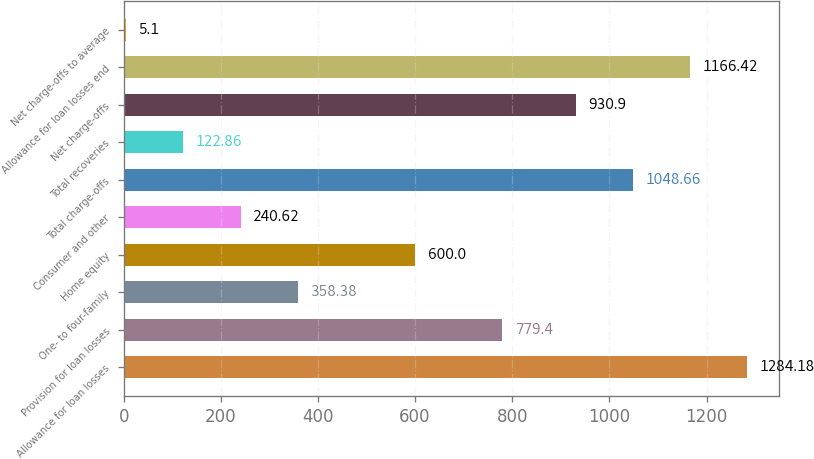<chart> <loc_0><loc_0><loc_500><loc_500><bar_chart><fcel>Allowance for loan losses<fcel>Provision for loan losses<fcel>One- to four-family<fcel>Home equity<fcel>Consumer and other<fcel>Total charge-offs<fcel>Total recoveries<fcel>Net charge-offs<fcel>Allowance for loan losses end<fcel>Net charge-offs to average<nl><fcel>1284.18<fcel>779.4<fcel>358.38<fcel>600<fcel>240.62<fcel>1048.66<fcel>122.86<fcel>930.9<fcel>1166.42<fcel>5.1<nl></chart> 